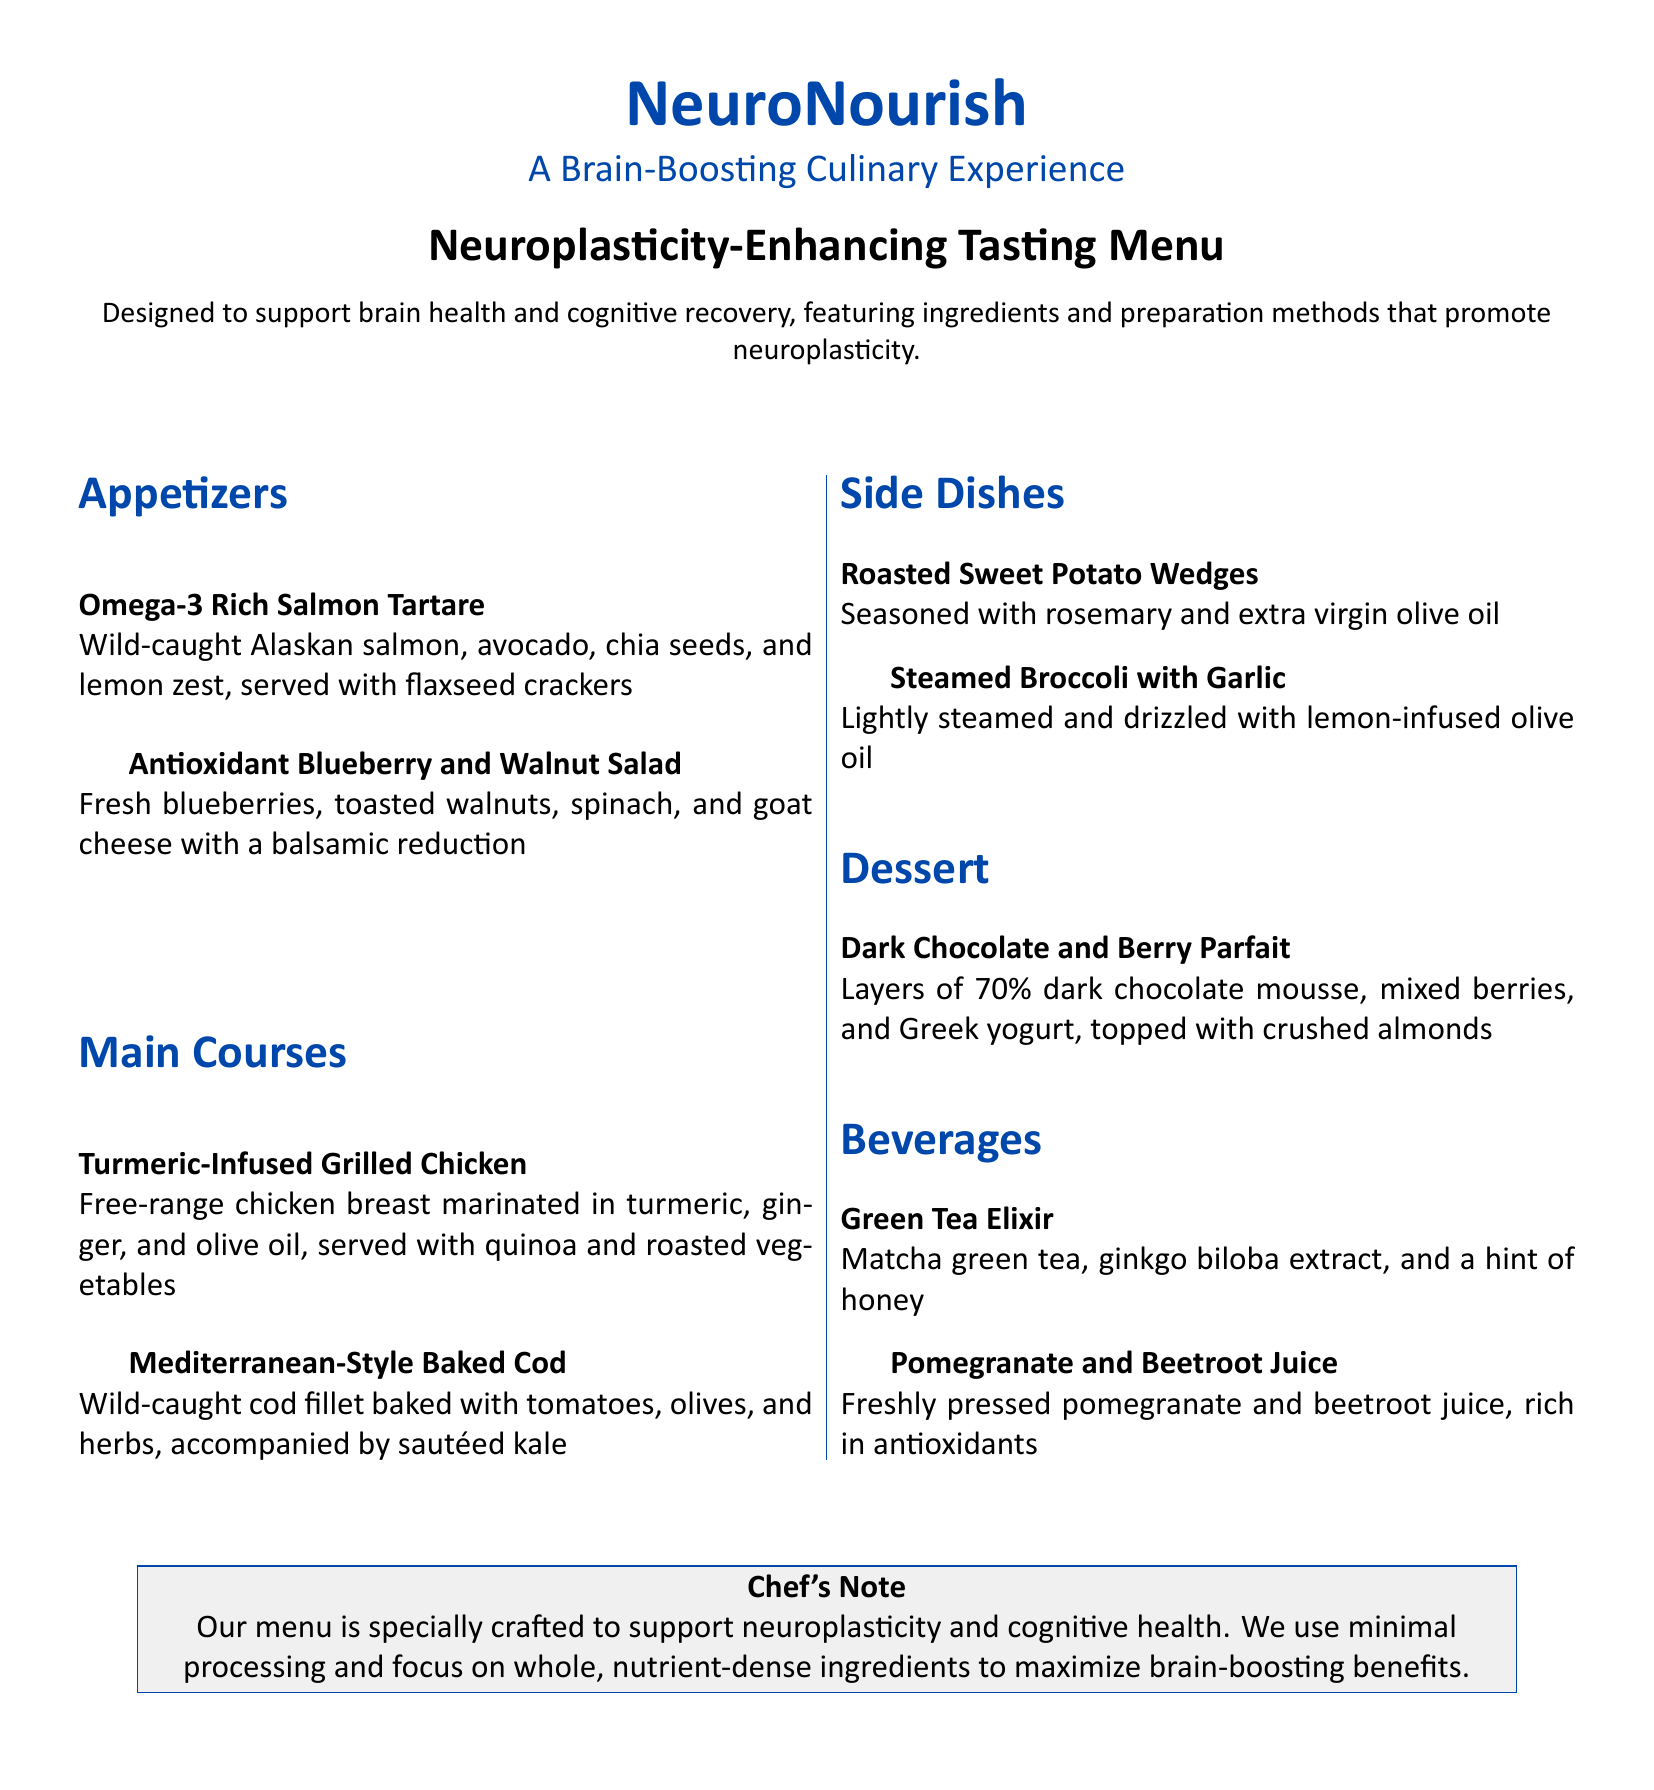What is the title of the menu? The title of the menu prominently displayed at the top of the document is "Neuroplasticity-Enhancing Tasting Menu."
Answer: Neuroplasticity-Enhancing Tasting Menu How many appetizers are listed? The document lists two appetizers under the appetizers section.
Answer: 2 What is the main ingredient in the Dark Chocolate and Berry Parfait? The primary ingredient mentioned for the dessert is 70% dark chocolate mousse.
Answer: 70% dark chocolate mousse Which beverage contains honey? The Green Tea Elixir is the beverage that has a hint of honey in its description.
Answer: Green Tea Elixir What preparation method is used for the Roasted Sweet Potato Wedges? The preparation method mentioned for the Roasted Sweet Potato Wedges is seasoning with rosemary and olive oil.
Answer: Seasoned with rosemary and olive oil What type of fish is featured in the main courses? The fish featured in the main courses is cod, specifically wild-caught cod fillet.
Answer: Cod What additional ingredient is paired with the matcha green tea in the beverage section? The additional ingredient paired with matcha green tea is ginkgo biloba extract.
Answer: Ginkgo biloba extract What type of oil is used in the Steamed Broccoli with Garlic? The type of oil used in the Steamed Broccoli with Garlic is lemon-infused olive oil.
Answer: Lemon-infused olive oil 